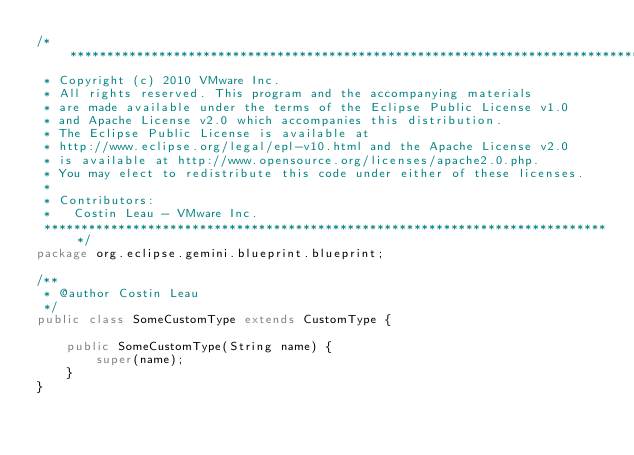Convert code to text. <code><loc_0><loc_0><loc_500><loc_500><_Java_>/******************************************************************************
 * Copyright (c) 2010 VMware Inc.
 * All rights reserved. This program and the accompanying materials
 * are made available under the terms of the Eclipse Public License v1.0
 * and Apache License v2.0 which accompanies this distribution. 
 * The Eclipse Public License is available at 
 * http://www.eclipse.org/legal/epl-v10.html and the Apache License v2.0
 * is available at http://www.opensource.org/licenses/apache2.0.php.
 * You may elect to redistribute this code under either of these licenses. 
 * 
 * Contributors:
 *   Costin Leau - VMware Inc.
 *****************************************************************************/
package org.eclipse.gemini.blueprint.blueprint;

/**
 * @author Costin Leau
 */
public class SomeCustomType extends CustomType {

	public SomeCustomType(String name) {
		super(name);
	}
}
</code> 